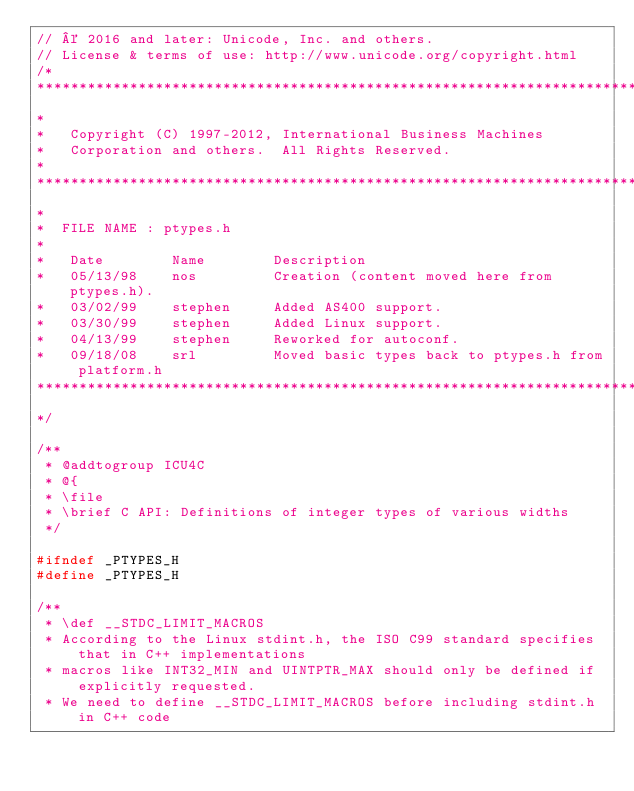<code> <loc_0><loc_0><loc_500><loc_500><_C_>// © 2016 and later: Unicode, Inc. and others.
// License & terms of use: http://www.unicode.org/copyright.html
/*
******************************************************************************
*
*   Copyright (C) 1997-2012, International Business Machines
*   Corporation and others.  All Rights Reserved.
*
******************************************************************************
*
*  FILE NAME : ptypes.h
*
*   Date        Name        Description
*   05/13/98    nos         Creation (content moved here from ptypes.h).
*   03/02/99    stephen     Added AS400 support.
*   03/30/99    stephen     Added Linux support.
*   04/13/99    stephen     Reworked for autoconf.
*   09/18/08    srl         Moved basic types back to ptypes.h from platform.h
******************************************************************************
*/

/**
 * @addtogroup ICU4C
 * @{
 * \file
 * \brief C API: Definitions of integer types of various widths
 */

#ifndef _PTYPES_H
#define _PTYPES_H

/**
 * \def __STDC_LIMIT_MACROS
 * According to the Linux stdint.h, the ISO C99 standard specifies that in C++ implementations
 * macros like INT32_MIN and UINTPTR_MAX should only be defined if explicitly requested.
 * We need to define __STDC_LIMIT_MACROS before including stdint.h in C++ code</code> 